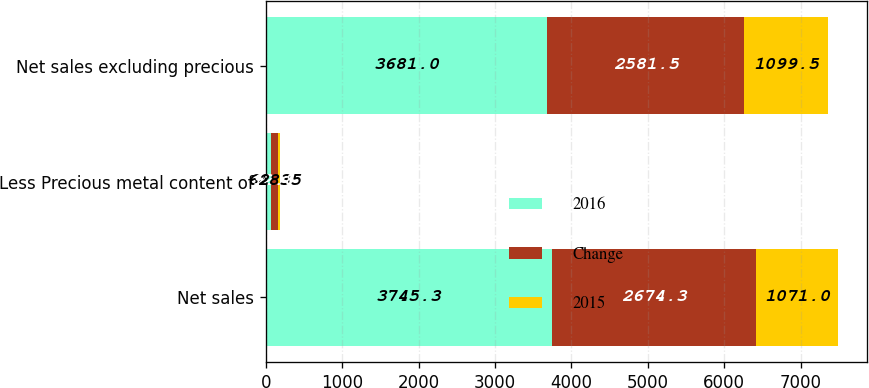<chart> <loc_0><loc_0><loc_500><loc_500><stacked_bar_chart><ecel><fcel>Net sales<fcel>Less Precious metal content of<fcel>Net sales excluding precious<nl><fcel>2016<fcel>3745.3<fcel>64.3<fcel>3681<nl><fcel>Change<fcel>2674.3<fcel>92.8<fcel>2581.5<nl><fcel>2015<fcel>1071<fcel>28.5<fcel>1099.5<nl></chart> 